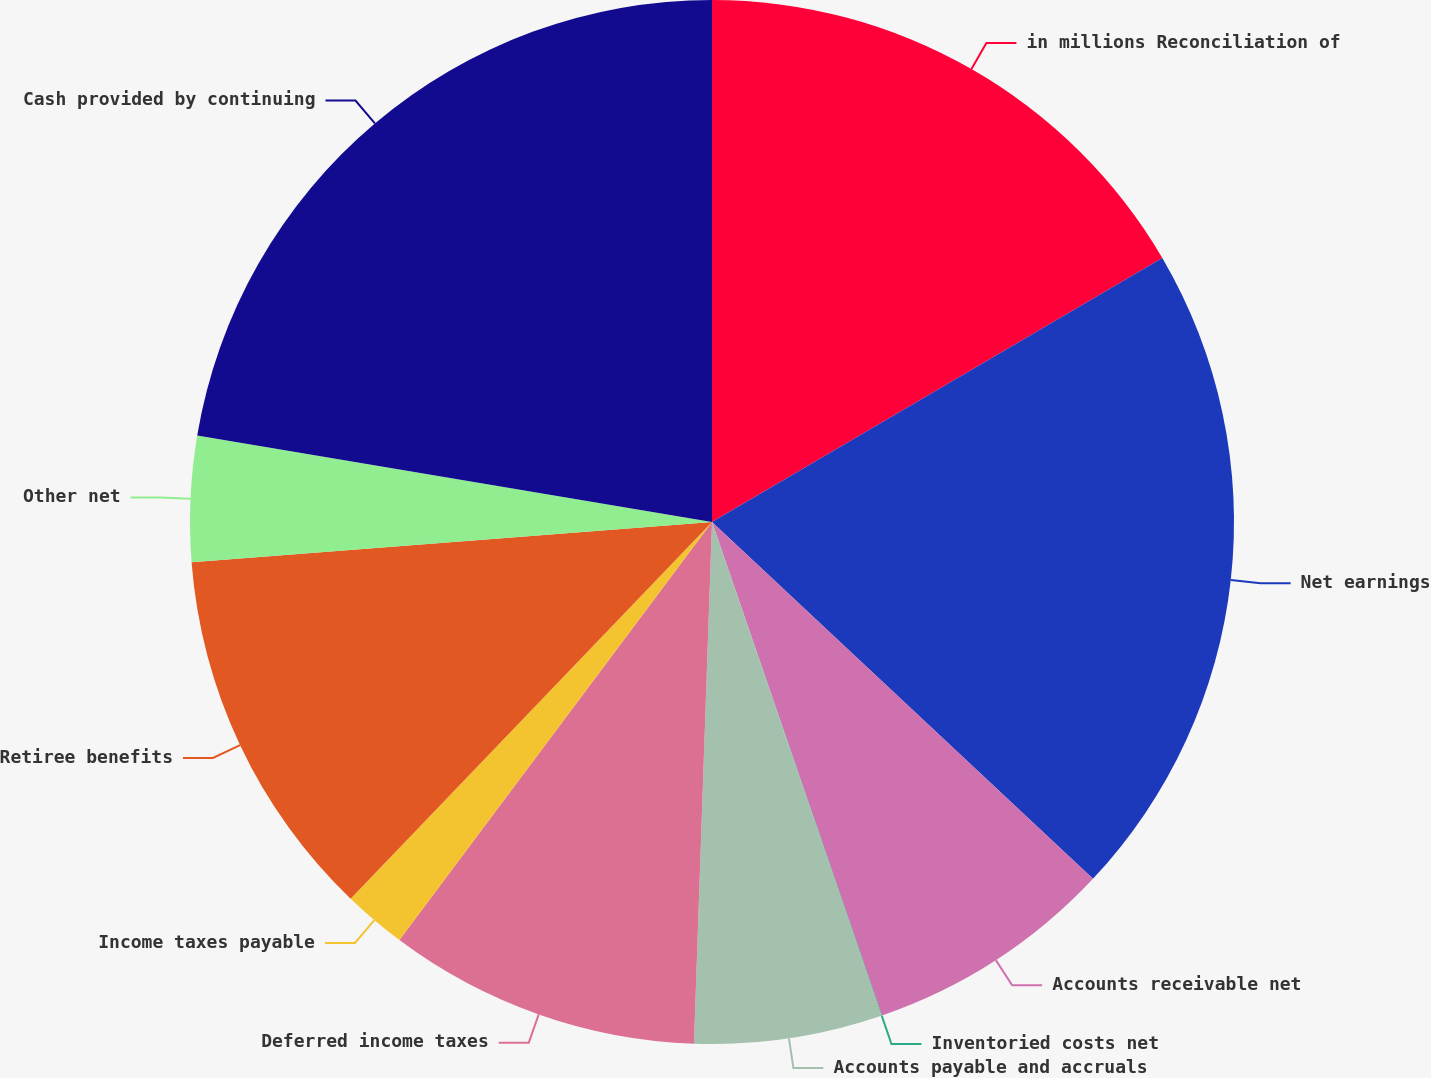Convert chart to OTSL. <chart><loc_0><loc_0><loc_500><loc_500><pie_chart><fcel>in millions Reconciliation of<fcel>Net earnings<fcel>Accounts receivable net<fcel>Inventoried costs net<fcel>Accounts payable and accruals<fcel>Deferred income taxes<fcel>Income taxes payable<fcel>Retiree benefits<fcel>Other net<fcel>Cash provided by continuing<nl><fcel>16.56%<fcel>20.42%<fcel>7.74%<fcel>0.02%<fcel>5.81%<fcel>9.67%<fcel>1.95%<fcel>11.6%<fcel>3.88%<fcel>22.35%<nl></chart> 